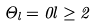Convert formula to latex. <formula><loc_0><loc_0><loc_500><loc_500>\Theta _ { l } = 0 l \geq 2</formula> 